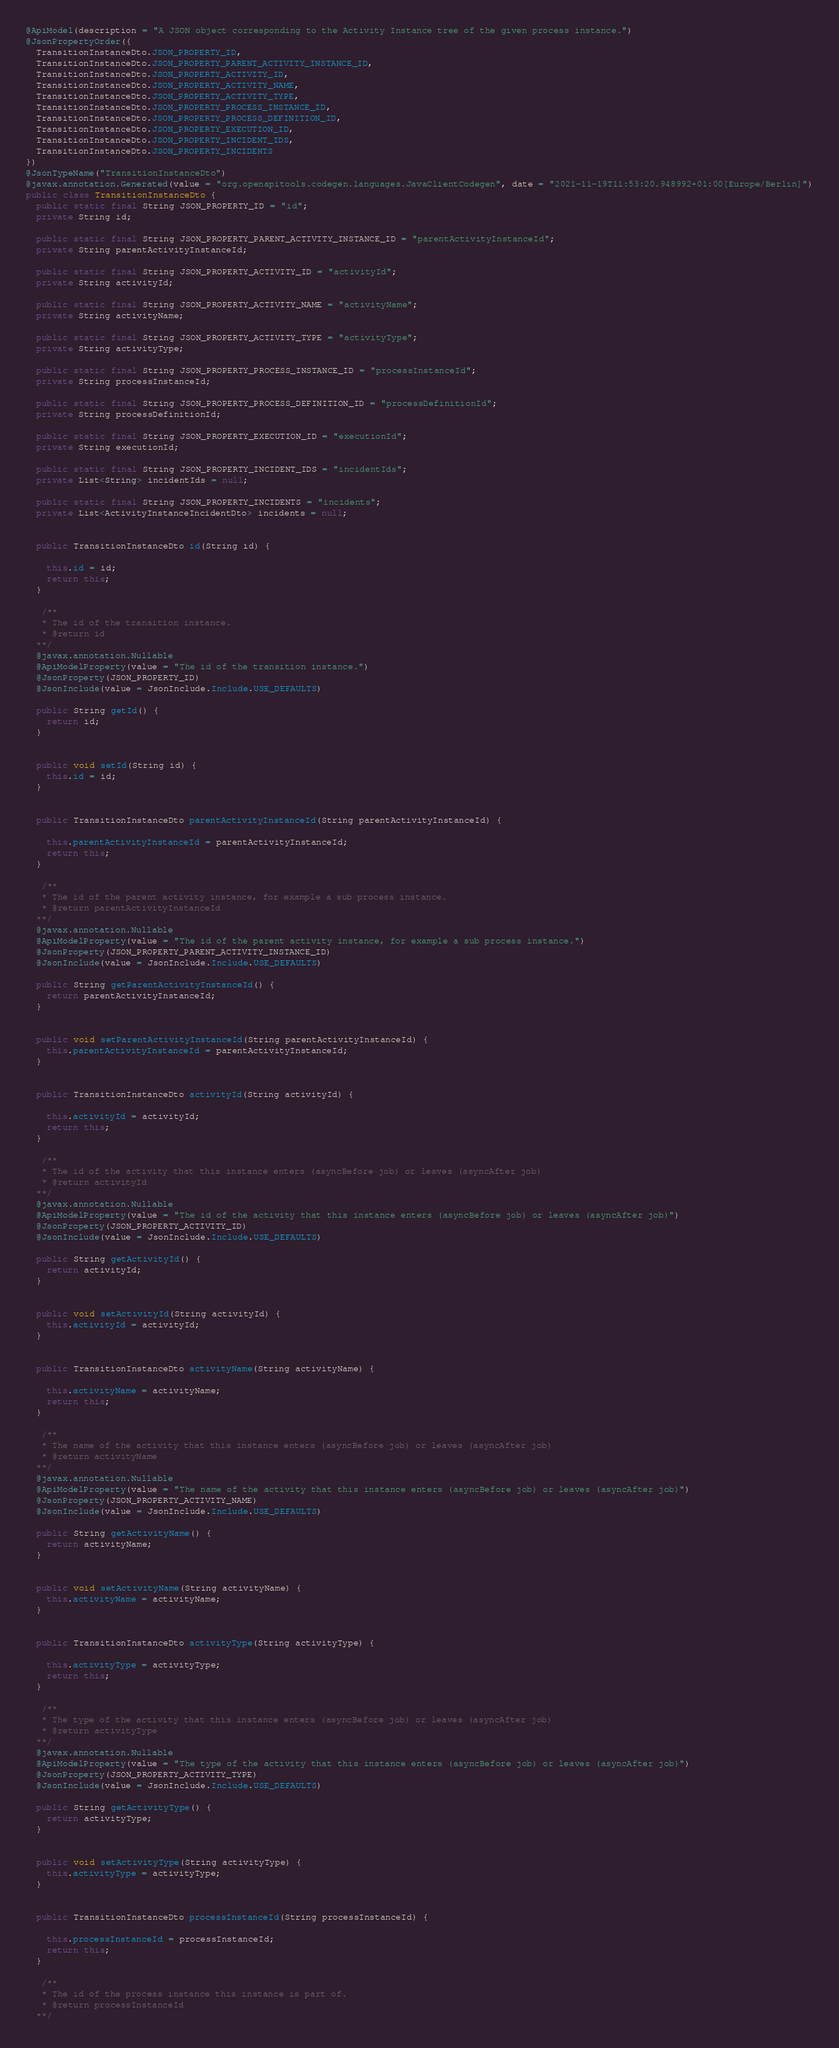Convert code to text. <code><loc_0><loc_0><loc_500><loc_500><_Java_>@ApiModel(description = "A JSON object corresponding to the Activity Instance tree of the given process instance.")
@JsonPropertyOrder({
  TransitionInstanceDto.JSON_PROPERTY_ID,
  TransitionInstanceDto.JSON_PROPERTY_PARENT_ACTIVITY_INSTANCE_ID,
  TransitionInstanceDto.JSON_PROPERTY_ACTIVITY_ID,
  TransitionInstanceDto.JSON_PROPERTY_ACTIVITY_NAME,
  TransitionInstanceDto.JSON_PROPERTY_ACTIVITY_TYPE,
  TransitionInstanceDto.JSON_PROPERTY_PROCESS_INSTANCE_ID,
  TransitionInstanceDto.JSON_PROPERTY_PROCESS_DEFINITION_ID,
  TransitionInstanceDto.JSON_PROPERTY_EXECUTION_ID,
  TransitionInstanceDto.JSON_PROPERTY_INCIDENT_IDS,
  TransitionInstanceDto.JSON_PROPERTY_INCIDENTS
})
@JsonTypeName("TransitionInstanceDto")
@javax.annotation.Generated(value = "org.openapitools.codegen.languages.JavaClientCodegen", date = "2021-11-19T11:53:20.948992+01:00[Europe/Berlin]")
public class TransitionInstanceDto {
  public static final String JSON_PROPERTY_ID = "id";
  private String id;

  public static final String JSON_PROPERTY_PARENT_ACTIVITY_INSTANCE_ID = "parentActivityInstanceId";
  private String parentActivityInstanceId;

  public static final String JSON_PROPERTY_ACTIVITY_ID = "activityId";
  private String activityId;

  public static final String JSON_PROPERTY_ACTIVITY_NAME = "activityName";
  private String activityName;

  public static final String JSON_PROPERTY_ACTIVITY_TYPE = "activityType";
  private String activityType;

  public static final String JSON_PROPERTY_PROCESS_INSTANCE_ID = "processInstanceId";
  private String processInstanceId;

  public static final String JSON_PROPERTY_PROCESS_DEFINITION_ID = "processDefinitionId";
  private String processDefinitionId;

  public static final String JSON_PROPERTY_EXECUTION_ID = "executionId";
  private String executionId;

  public static final String JSON_PROPERTY_INCIDENT_IDS = "incidentIds";
  private List<String> incidentIds = null;

  public static final String JSON_PROPERTY_INCIDENTS = "incidents";
  private List<ActivityInstanceIncidentDto> incidents = null;


  public TransitionInstanceDto id(String id) {
    
    this.id = id;
    return this;
  }

   /**
   * The id of the transition instance.
   * @return id
  **/
  @javax.annotation.Nullable
  @ApiModelProperty(value = "The id of the transition instance.")
  @JsonProperty(JSON_PROPERTY_ID)
  @JsonInclude(value = JsonInclude.Include.USE_DEFAULTS)

  public String getId() {
    return id;
  }


  public void setId(String id) {
    this.id = id;
  }


  public TransitionInstanceDto parentActivityInstanceId(String parentActivityInstanceId) {
    
    this.parentActivityInstanceId = parentActivityInstanceId;
    return this;
  }

   /**
   * The id of the parent activity instance, for example a sub process instance.
   * @return parentActivityInstanceId
  **/
  @javax.annotation.Nullable
  @ApiModelProperty(value = "The id of the parent activity instance, for example a sub process instance.")
  @JsonProperty(JSON_PROPERTY_PARENT_ACTIVITY_INSTANCE_ID)
  @JsonInclude(value = JsonInclude.Include.USE_DEFAULTS)

  public String getParentActivityInstanceId() {
    return parentActivityInstanceId;
  }


  public void setParentActivityInstanceId(String parentActivityInstanceId) {
    this.parentActivityInstanceId = parentActivityInstanceId;
  }


  public TransitionInstanceDto activityId(String activityId) {
    
    this.activityId = activityId;
    return this;
  }

   /**
   * The id of the activity that this instance enters (asyncBefore job) or leaves (asyncAfter job)
   * @return activityId
  **/
  @javax.annotation.Nullable
  @ApiModelProperty(value = "The id of the activity that this instance enters (asyncBefore job) or leaves (asyncAfter job)")
  @JsonProperty(JSON_PROPERTY_ACTIVITY_ID)
  @JsonInclude(value = JsonInclude.Include.USE_DEFAULTS)

  public String getActivityId() {
    return activityId;
  }


  public void setActivityId(String activityId) {
    this.activityId = activityId;
  }


  public TransitionInstanceDto activityName(String activityName) {
    
    this.activityName = activityName;
    return this;
  }

   /**
   * The name of the activity that this instance enters (asyncBefore job) or leaves (asyncAfter job)
   * @return activityName
  **/
  @javax.annotation.Nullable
  @ApiModelProperty(value = "The name of the activity that this instance enters (asyncBefore job) or leaves (asyncAfter job)")
  @JsonProperty(JSON_PROPERTY_ACTIVITY_NAME)
  @JsonInclude(value = JsonInclude.Include.USE_DEFAULTS)

  public String getActivityName() {
    return activityName;
  }


  public void setActivityName(String activityName) {
    this.activityName = activityName;
  }


  public TransitionInstanceDto activityType(String activityType) {
    
    this.activityType = activityType;
    return this;
  }

   /**
   * The type of the activity that this instance enters (asyncBefore job) or leaves (asyncAfter job)
   * @return activityType
  **/
  @javax.annotation.Nullable
  @ApiModelProperty(value = "The type of the activity that this instance enters (asyncBefore job) or leaves (asyncAfter job)")
  @JsonProperty(JSON_PROPERTY_ACTIVITY_TYPE)
  @JsonInclude(value = JsonInclude.Include.USE_DEFAULTS)

  public String getActivityType() {
    return activityType;
  }


  public void setActivityType(String activityType) {
    this.activityType = activityType;
  }


  public TransitionInstanceDto processInstanceId(String processInstanceId) {
    
    this.processInstanceId = processInstanceId;
    return this;
  }

   /**
   * The id of the process instance this instance is part of.
   * @return processInstanceId
  **/</code> 